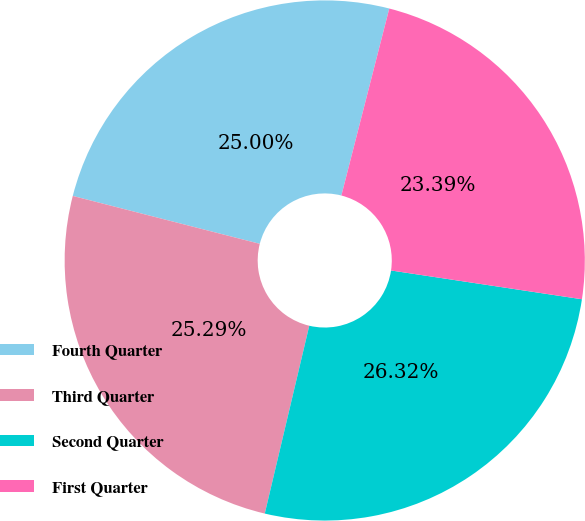Convert chart. <chart><loc_0><loc_0><loc_500><loc_500><pie_chart><fcel>Fourth Quarter<fcel>Third Quarter<fcel>Second Quarter<fcel>First Quarter<nl><fcel>25.0%<fcel>25.29%<fcel>26.32%<fcel>23.39%<nl></chart> 